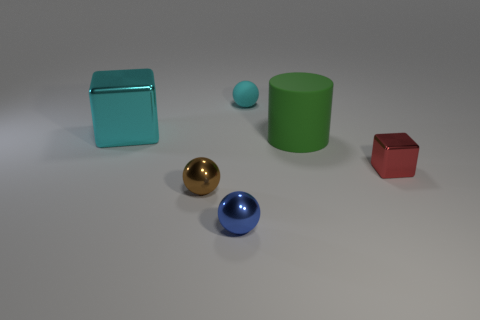What is the material of the ball that is the same color as the large shiny cube?
Your response must be concise. Rubber. How many other objects are there of the same material as the small red thing?
Offer a very short reply. 3. Is the shape of the red thing the same as the small metal thing that is left of the blue thing?
Make the answer very short. No. There is a large cyan thing that is the same material as the brown thing; what is its shape?
Make the answer very short. Cube. Is the number of matte cylinders that are behind the large cyan cube greater than the number of cyan shiny blocks that are in front of the brown metal ball?
Offer a very short reply. No. How many objects are big yellow metallic cubes or tiny blue things?
Provide a short and direct response. 1. How many other things are the same color as the large shiny cube?
Offer a very short reply. 1. What shape is the cyan rubber thing that is the same size as the red cube?
Your response must be concise. Sphere. There is a small ball behind the cyan shiny object; what is its color?
Offer a terse response. Cyan. How many things are either spheres that are behind the cyan metallic thing or cyan matte things behind the tiny brown object?
Give a very brief answer. 1. 